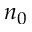<formula> <loc_0><loc_0><loc_500><loc_500>n _ { 0 }</formula> 